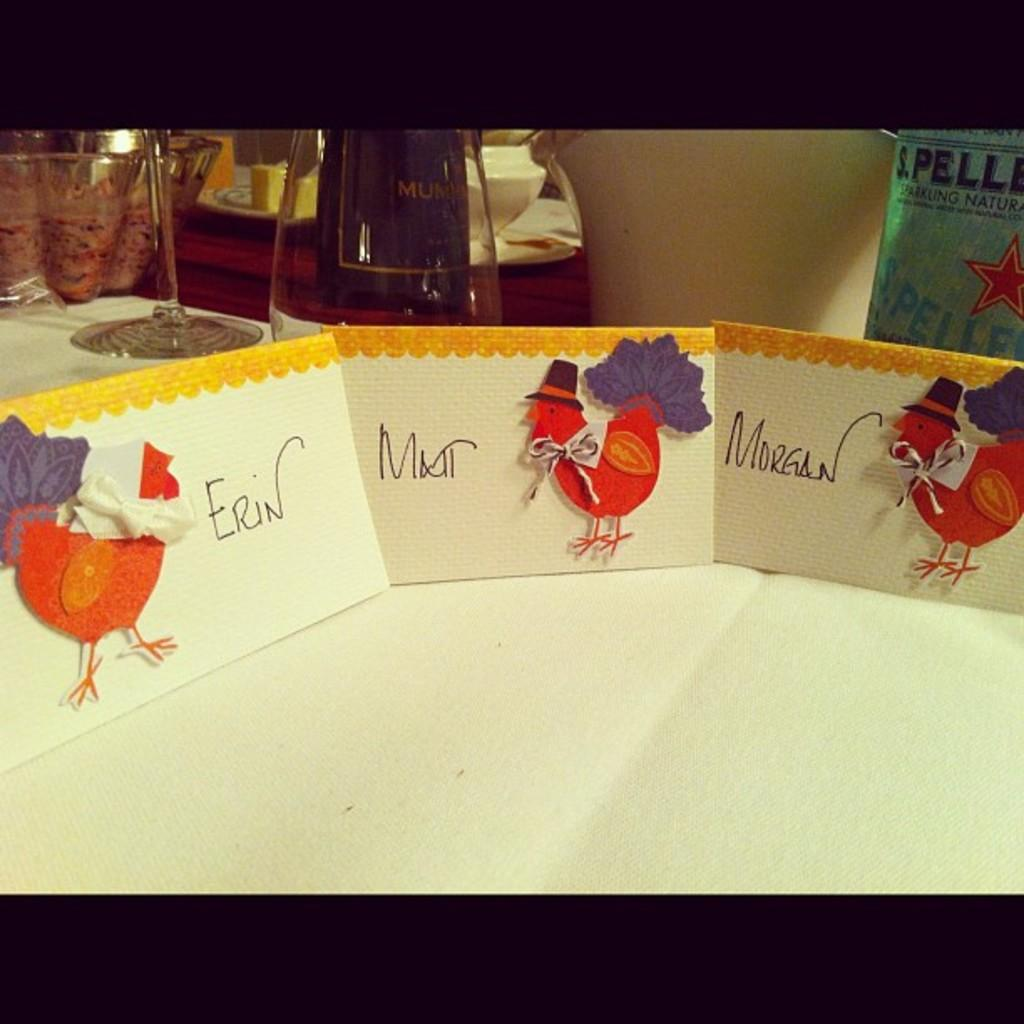<image>
Relay a brief, clear account of the picture shown. Three cards that show turkeys and the name Erin on the left. 